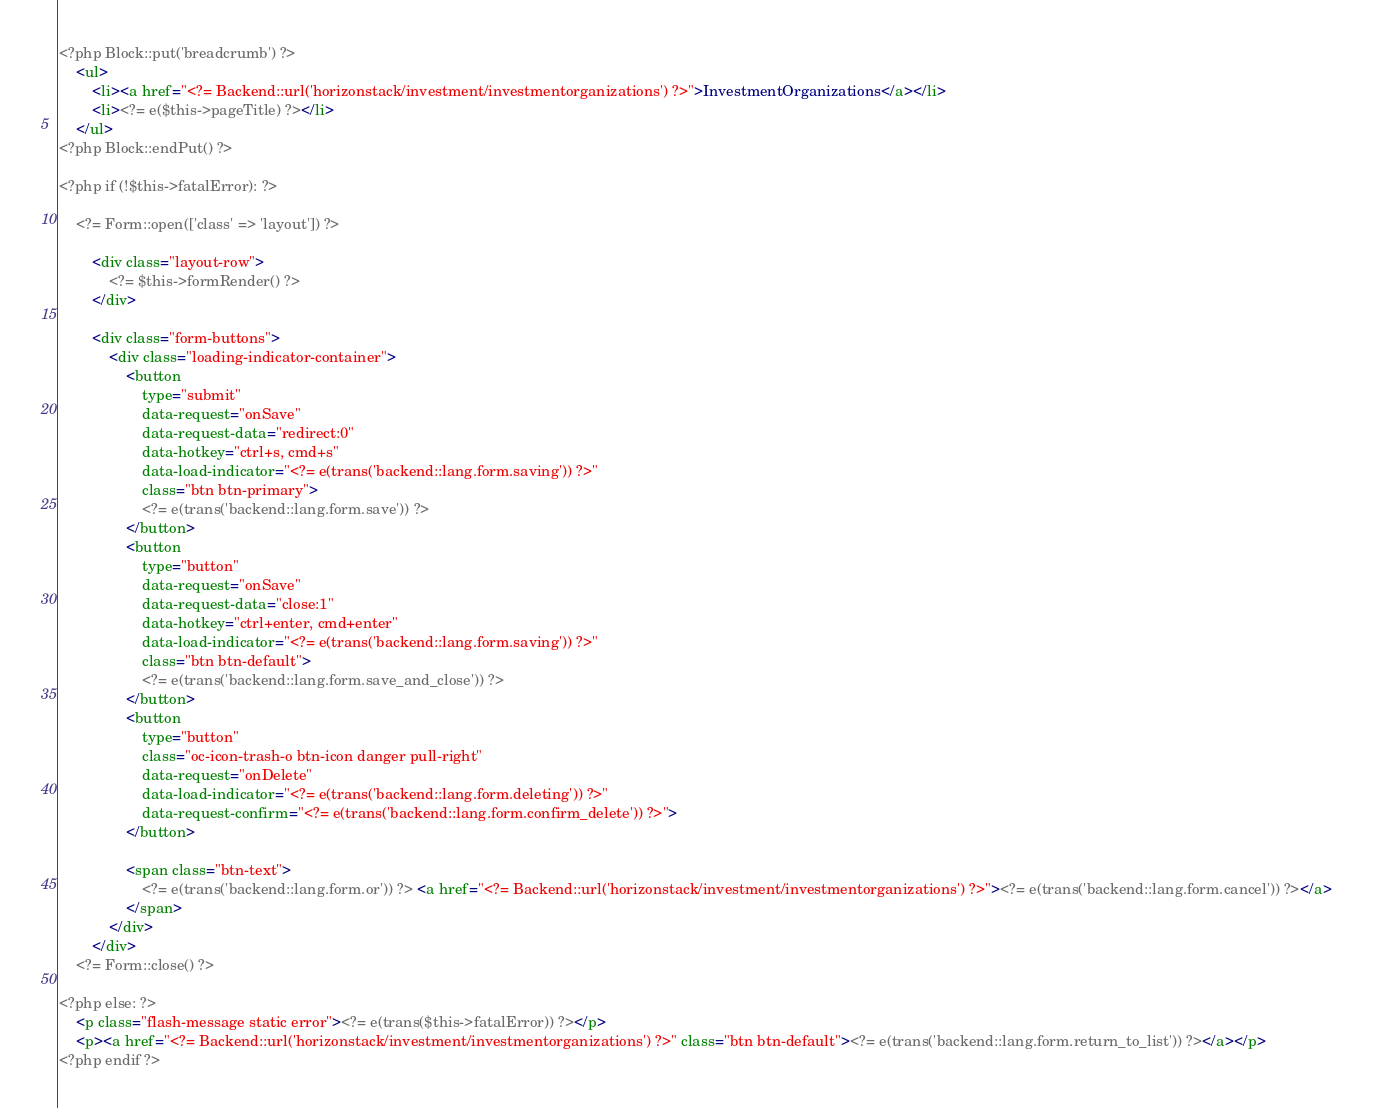<code> <loc_0><loc_0><loc_500><loc_500><_HTML_><?php Block::put('breadcrumb') ?>
    <ul>
        <li><a href="<?= Backend::url('horizonstack/investment/investmentorganizations') ?>">InvestmentOrganizations</a></li>
        <li><?= e($this->pageTitle) ?></li>
    </ul>
<?php Block::endPut() ?>

<?php if (!$this->fatalError): ?>

    <?= Form::open(['class' => 'layout']) ?>

        <div class="layout-row">
            <?= $this->formRender() ?>
        </div>

        <div class="form-buttons">
            <div class="loading-indicator-container">
                <button
                    type="submit"
                    data-request="onSave"
                    data-request-data="redirect:0"
                    data-hotkey="ctrl+s, cmd+s"
                    data-load-indicator="<?= e(trans('backend::lang.form.saving')) ?>"
                    class="btn btn-primary">
                    <?= e(trans('backend::lang.form.save')) ?>
                </button>
                <button
                    type="button"
                    data-request="onSave"
                    data-request-data="close:1"
                    data-hotkey="ctrl+enter, cmd+enter"
                    data-load-indicator="<?= e(trans('backend::lang.form.saving')) ?>"
                    class="btn btn-default">
                    <?= e(trans('backend::lang.form.save_and_close')) ?>
                </button>
                <button
                    type="button"
                    class="oc-icon-trash-o btn-icon danger pull-right"
                    data-request="onDelete"
                    data-load-indicator="<?= e(trans('backend::lang.form.deleting')) ?>"
                    data-request-confirm="<?= e(trans('backend::lang.form.confirm_delete')) ?>">
                </button>

                <span class="btn-text">
                    <?= e(trans('backend::lang.form.or')) ?> <a href="<?= Backend::url('horizonstack/investment/investmentorganizations') ?>"><?= e(trans('backend::lang.form.cancel')) ?></a>
                </span>
            </div>
        </div>
    <?= Form::close() ?>

<?php else: ?>
    <p class="flash-message static error"><?= e(trans($this->fatalError)) ?></p>
    <p><a href="<?= Backend::url('horizonstack/investment/investmentorganizations') ?>" class="btn btn-default"><?= e(trans('backend::lang.form.return_to_list')) ?></a></p>
<?php endif ?></code> 